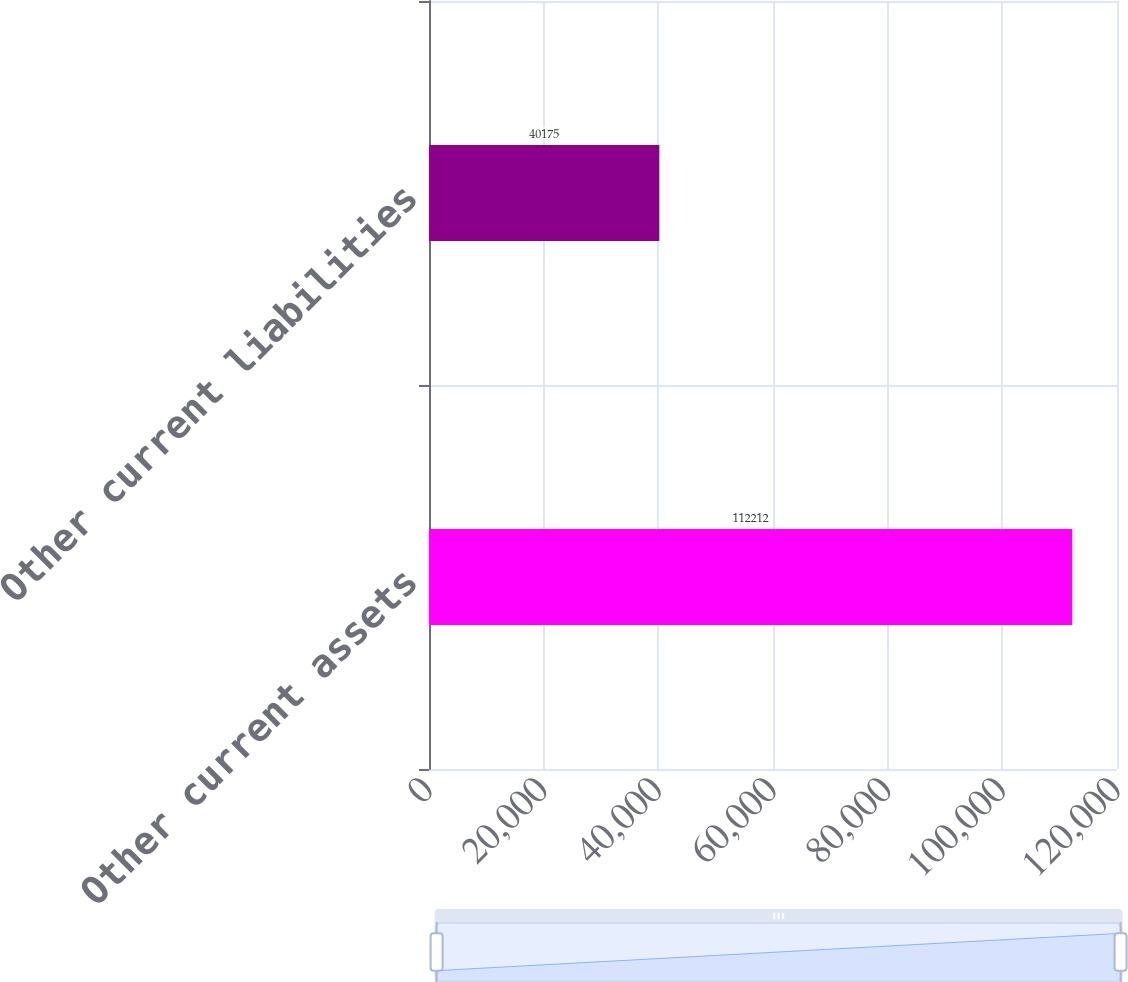Convert chart to OTSL. <chart><loc_0><loc_0><loc_500><loc_500><bar_chart><fcel>Other current assets<fcel>Other current liabilities<nl><fcel>112212<fcel>40175<nl></chart> 